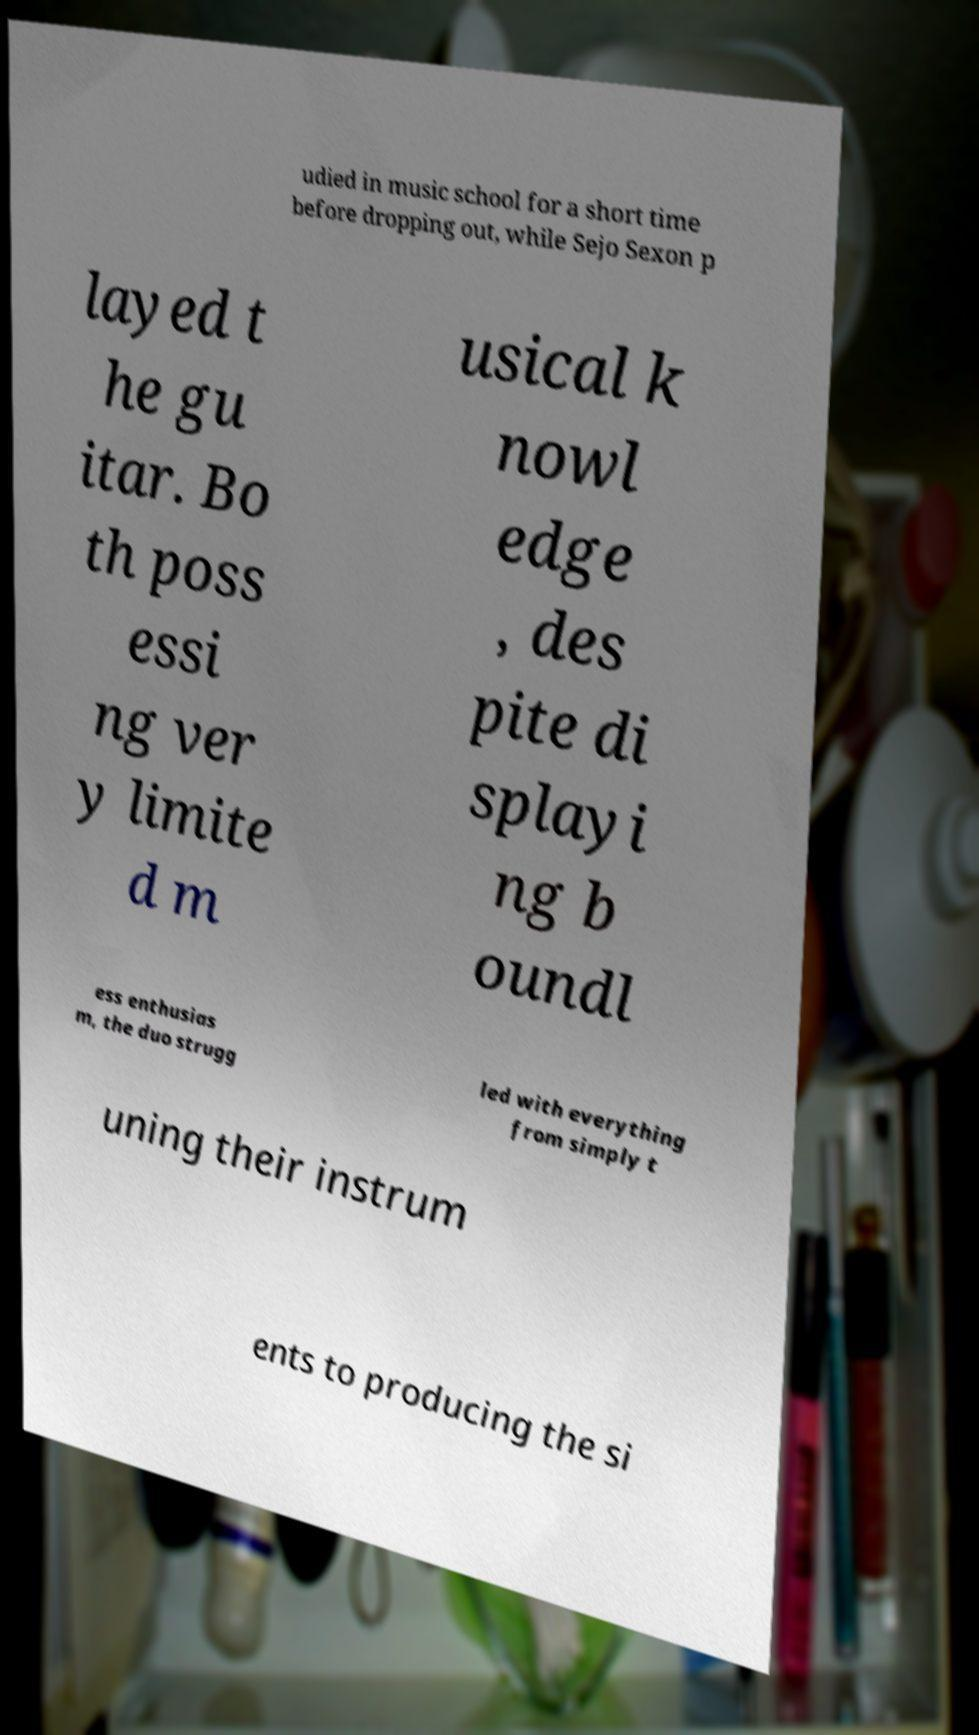Could you assist in decoding the text presented in this image and type it out clearly? udied in music school for a short time before dropping out, while Sejo Sexon p layed t he gu itar. Bo th poss essi ng ver y limite d m usical k nowl edge , des pite di splayi ng b oundl ess enthusias m, the duo strugg led with everything from simply t uning their instrum ents to producing the si 